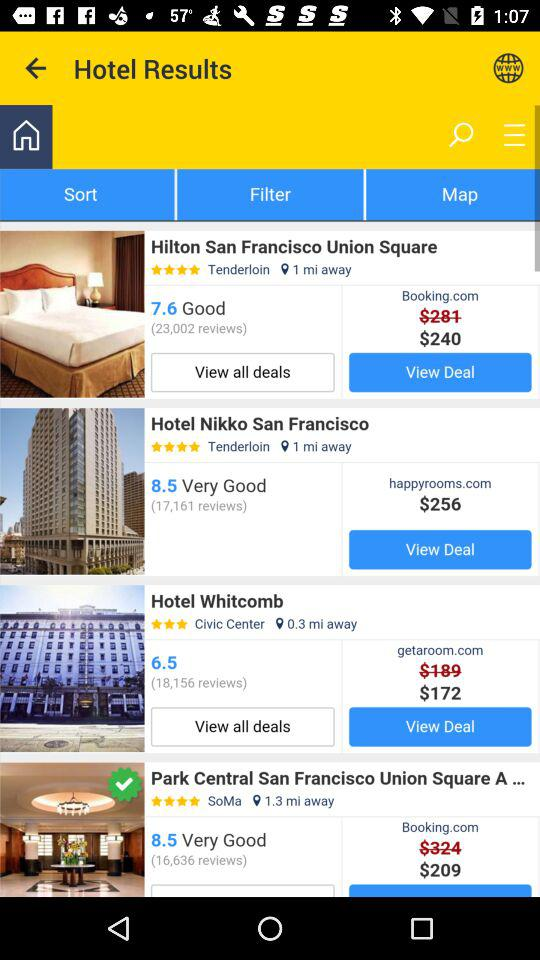How many reviews are there for "Hotel Whitcomb"? There are 18,156 reviews. 